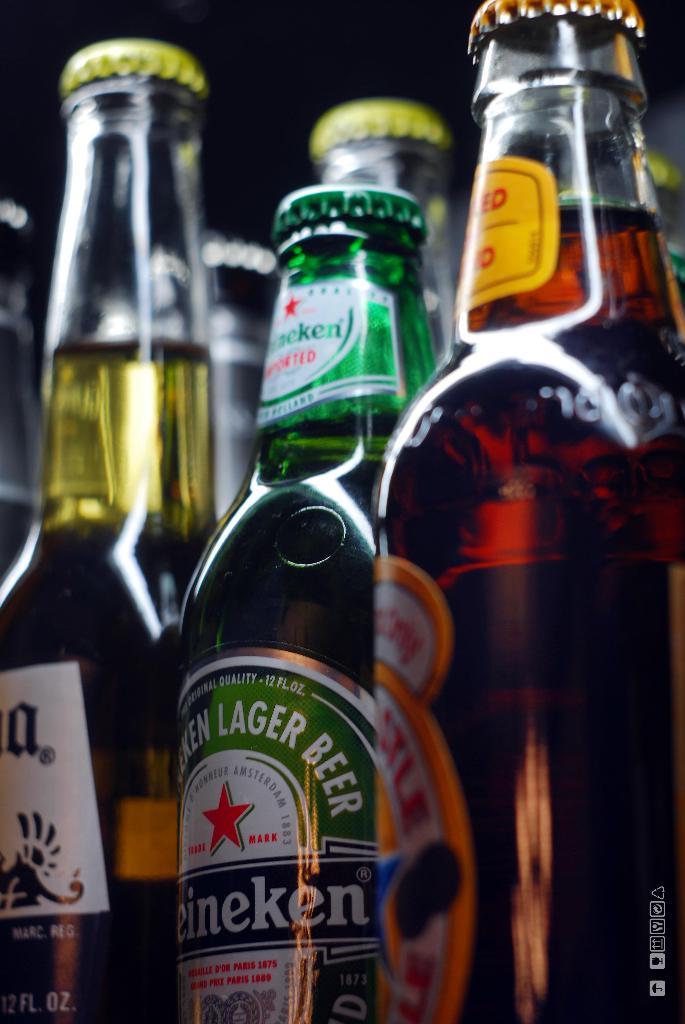What beverage is in the bottle?
Your answer should be compact. Beer. 